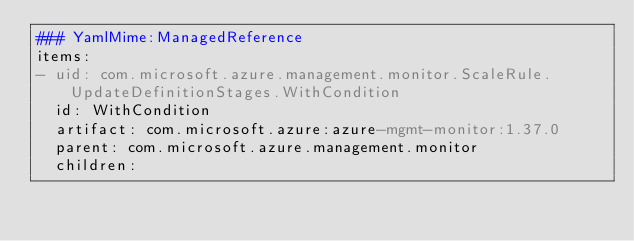Convert code to text. <code><loc_0><loc_0><loc_500><loc_500><_YAML_>### YamlMime:ManagedReference
items:
- uid: com.microsoft.azure.management.monitor.ScaleRule.UpdateDefinitionStages.WithCondition
  id: WithCondition
  artifact: com.microsoft.azure:azure-mgmt-monitor:1.37.0
  parent: com.microsoft.azure.management.monitor
  children:</code> 